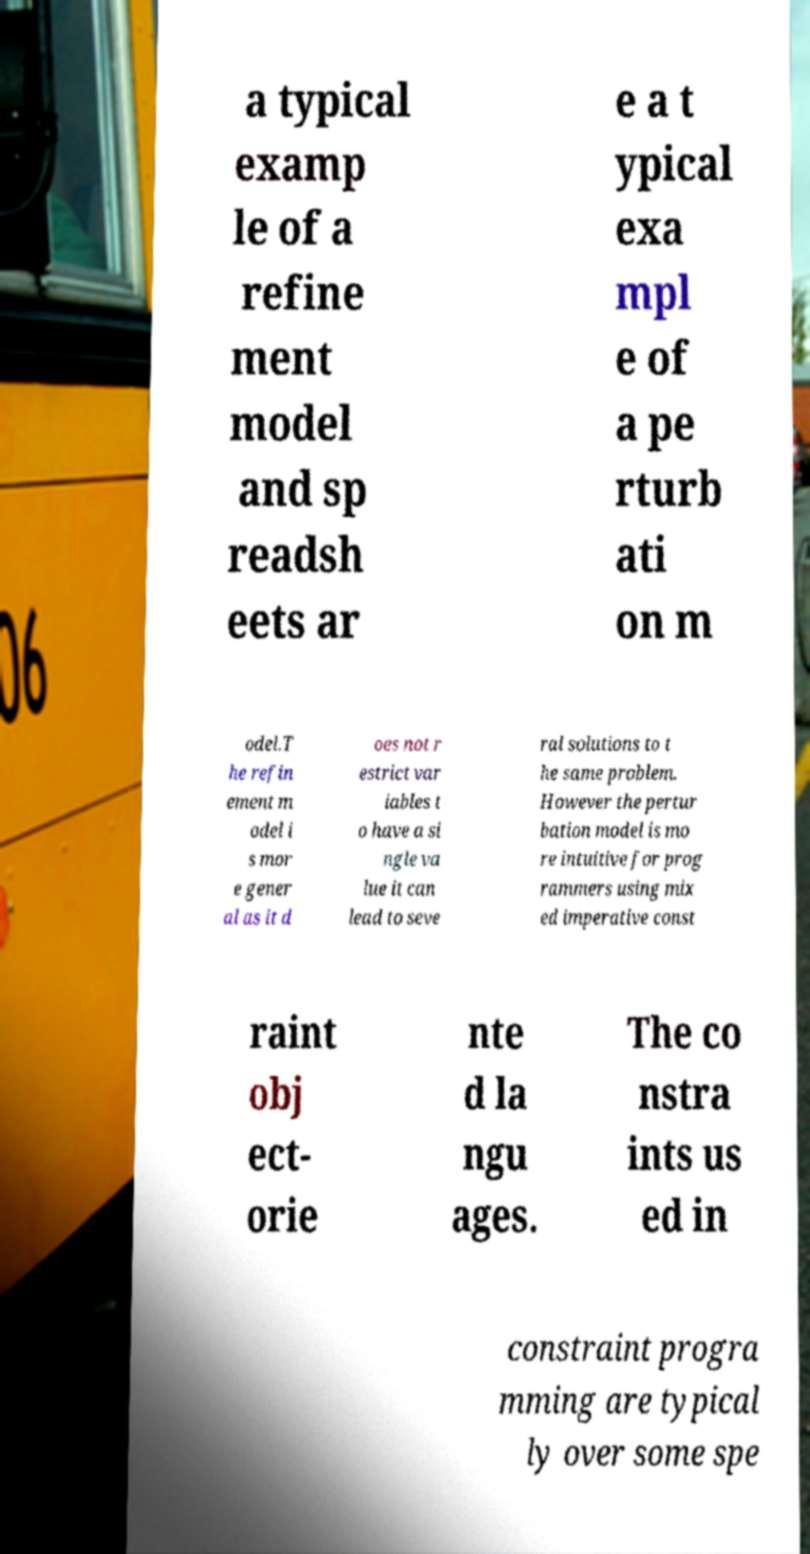There's text embedded in this image that I need extracted. Can you transcribe it verbatim? a typical examp le of a refine ment model and sp readsh eets ar e a t ypical exa mpl e of a pe rturb ati on m odel.T he refin ement m odel i s mor e gener al as it d oes not r estrict var iables t o have a si ngle va lue it can lead to seve ral solutions to t he same problem. However the pertur bation model is mo re intuitive for prog rammers using mix ed imperative const raint obj ect- orie nte d la ngu ages. The co nstra ints us ed in constraint progra mming are typical ly over some spe 